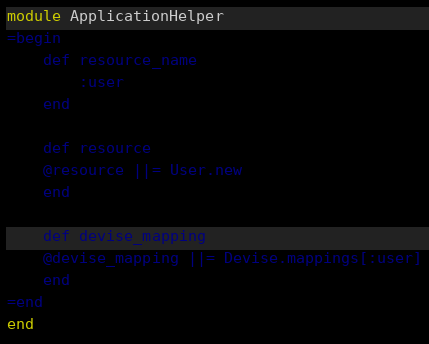Convert code to text. <code><loc_0><loc_0><loc_500><loc_500><_Ruby_>module ApplicationHelper
=begin
    def resource_name
        :user
    end
       
    def resource
    @resource ||= User.new
    end
    
    def devise_mapping
    @devise_mapping ||= Devise.mappings[:user]
    end
=end
end
</code> 